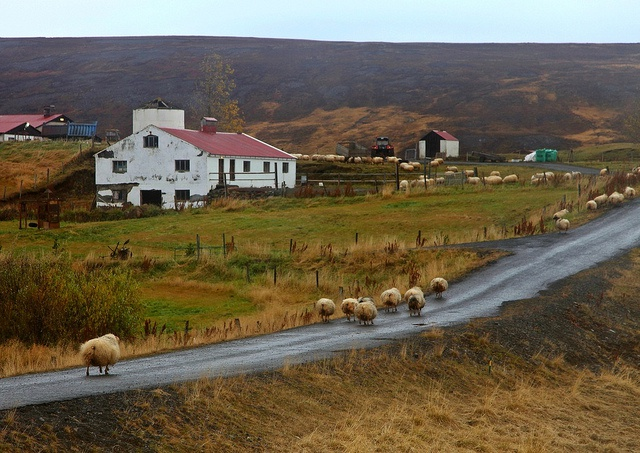Describe the objects in this image and their specific colors. I can see sheep in white, olive, black, and gray tones, sheep in white, tan, maroon, and black tones, sheep in white, black, tan, gray, and maroon tones, sheep in white, black, tan, and maroon tones, and truck in white, black, gray, and maroon tones in this image. 